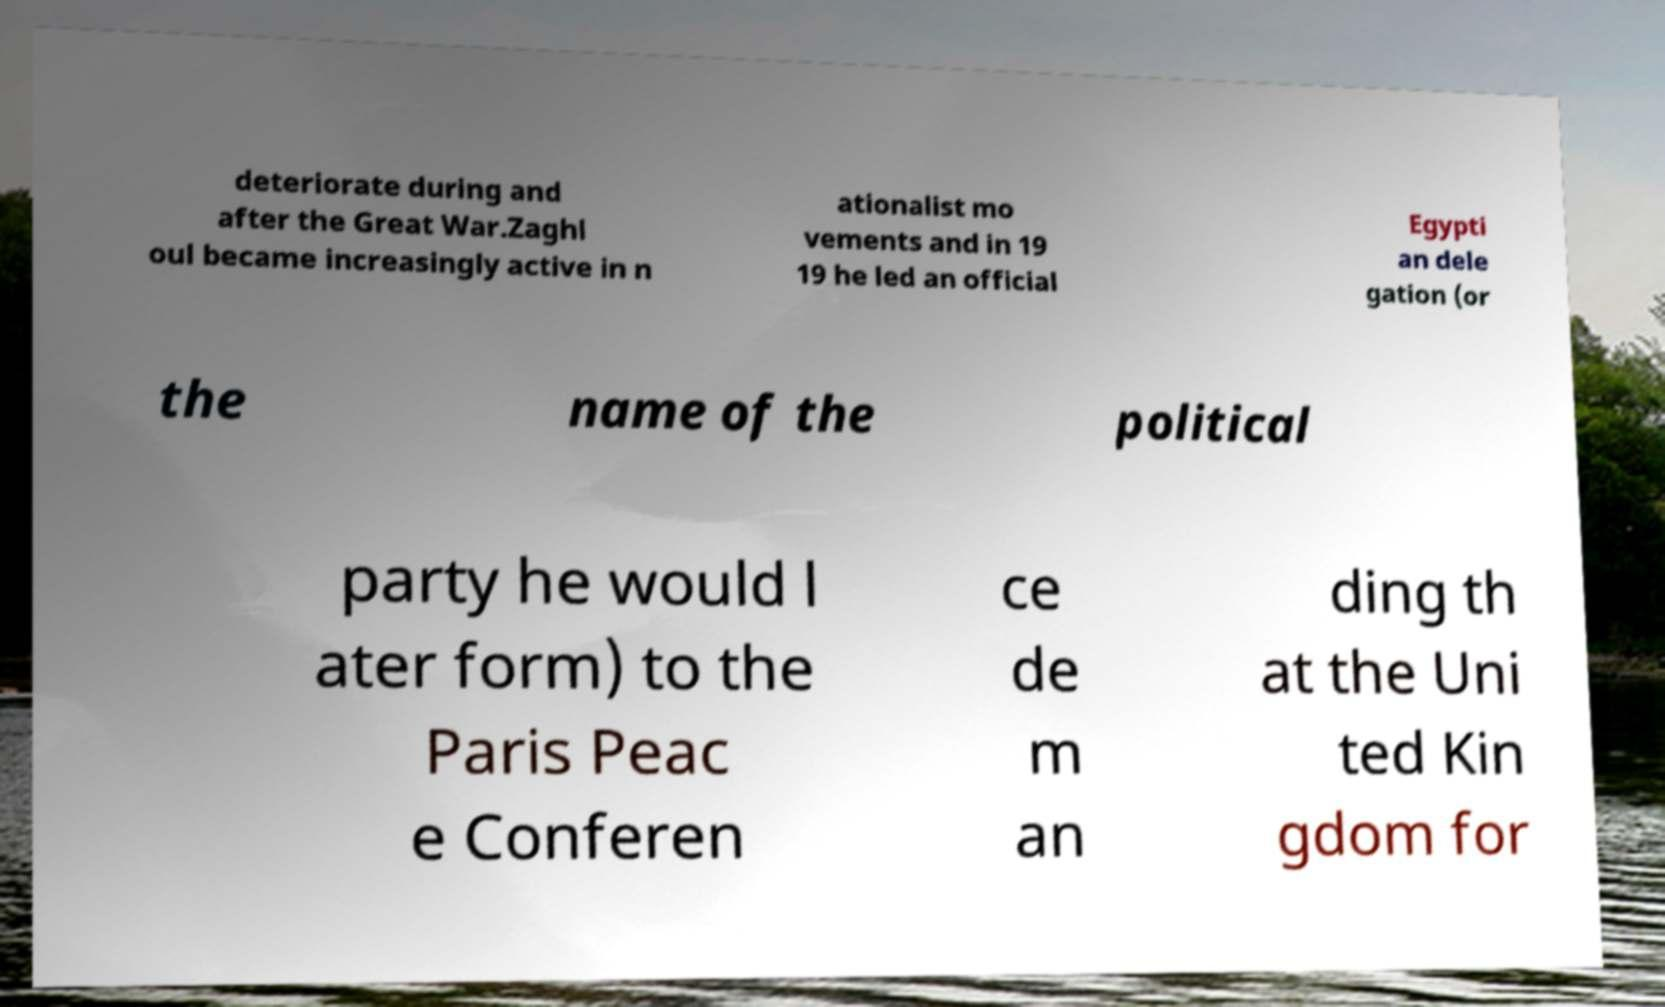What messages or text are displayed in this image? I need them in a readable, typed format. deteriorate during and after the Great War.Zaghl oul became increasingly active in n ationalist mo vements and in 19 19 he led an official Egypti an dele gation (or the name of the political party he would l ater form) to the Paris Peac e Conferen ce de m an ding th at the Uni ted Kin gdom for 